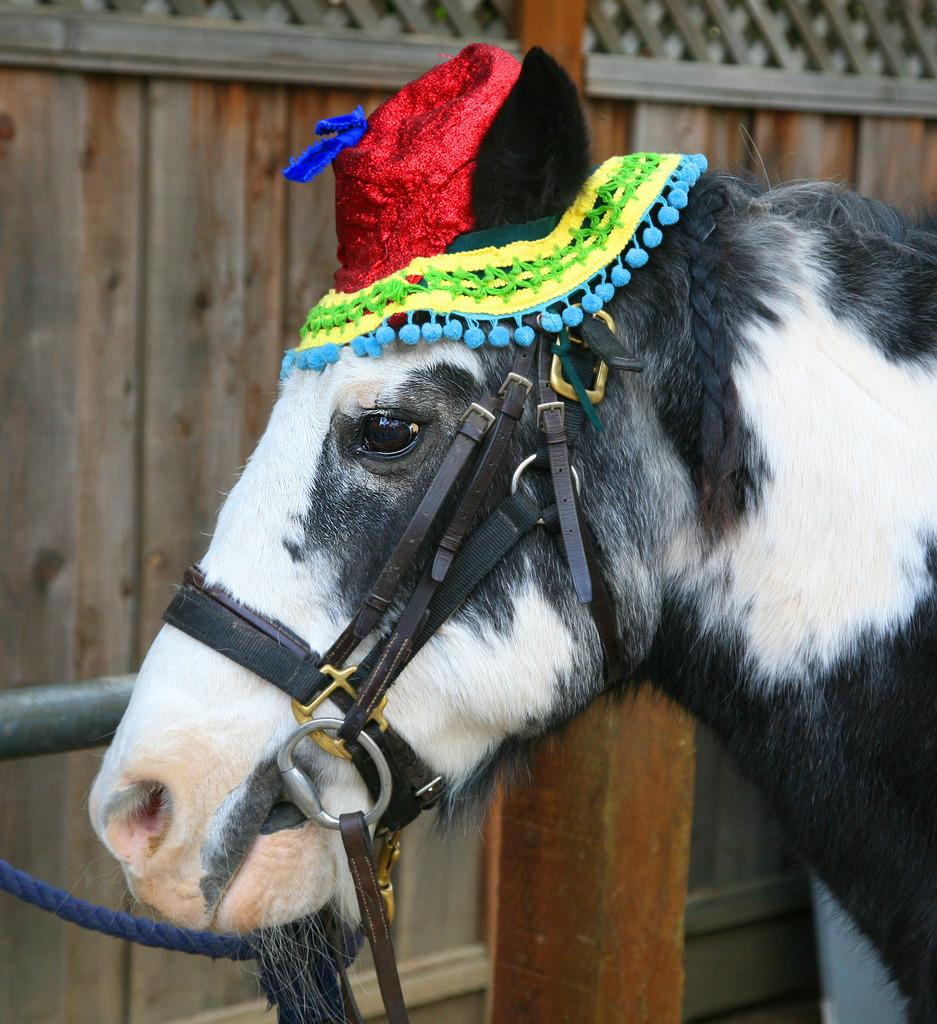What is the main subject in the center of the image? There is a horse in the center of the image. What is unique about the horse's appearance? The horse has a hat on it. What can be seen in the background of the image? There is a fence in the background of the image. What type of disease is the boy in the image suffering from? There is no boy present in the image, so it is not possible to determine if anyone is suffering from a disease. 